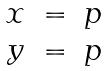<formula> <loc_0><loc_0><loc_500><loc_500>\begin{matrix} x & = & p \\ y & = & p \end{matrix}</formula> 